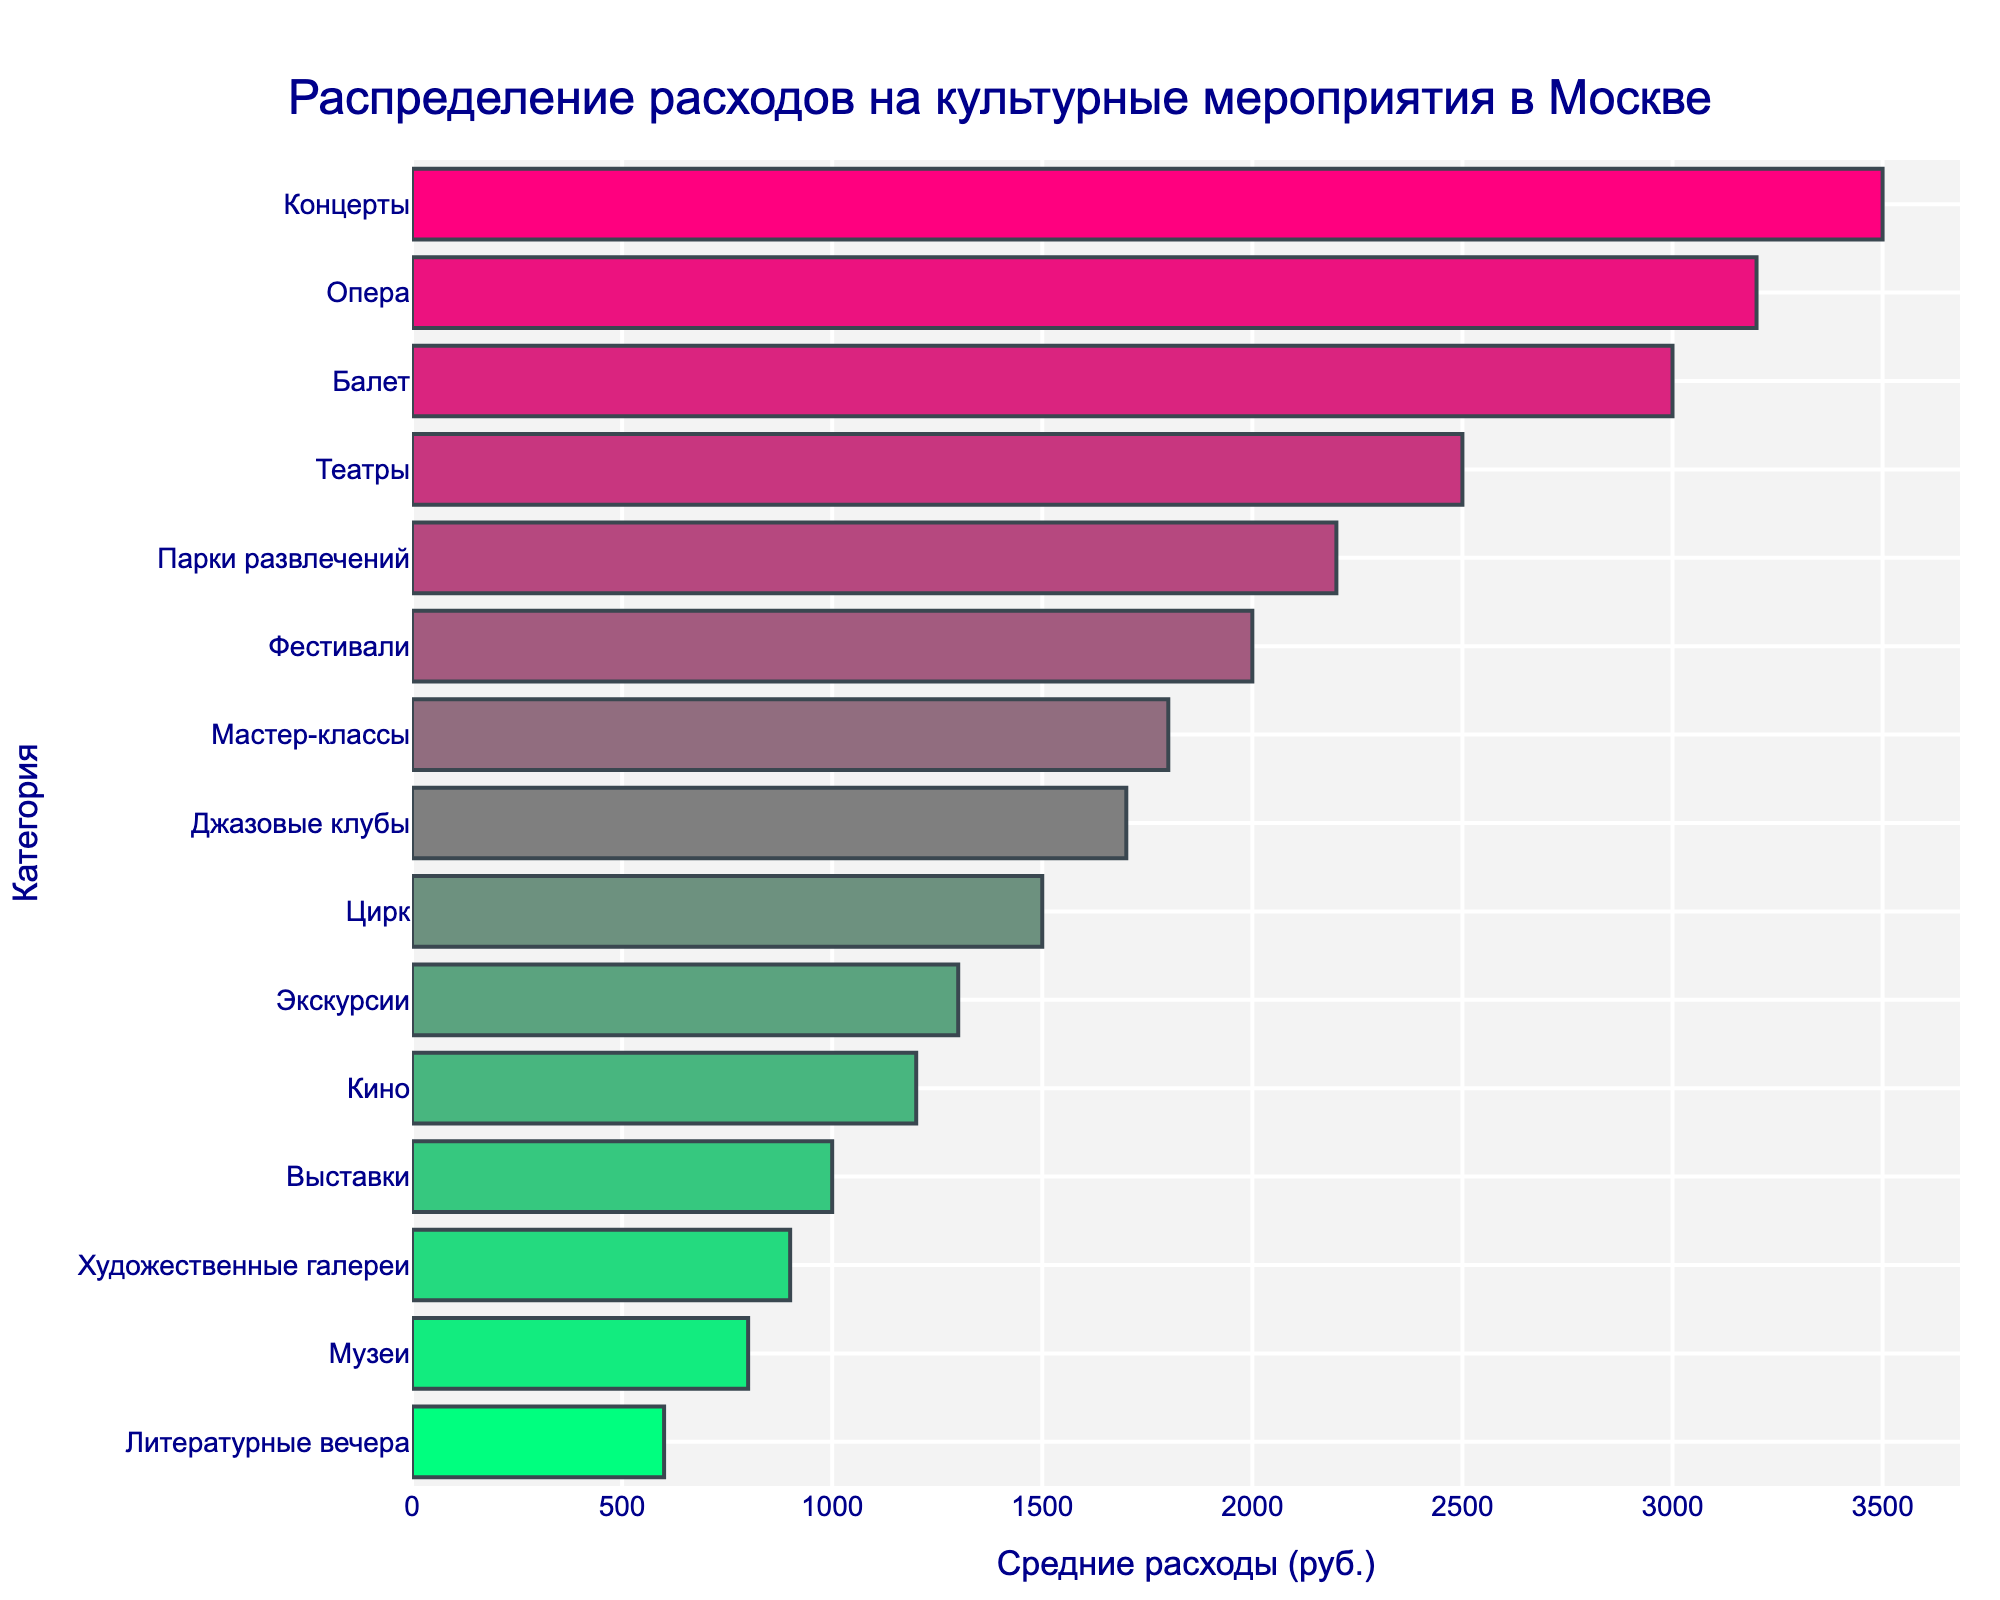Какая категория имеет наибольшие средние расходы? Внимательно глядя на горизонтальные столбцы в графике, категория с самым длинным столбцом означает наибольшие средние расходы. В данном случае, это категория "Концерты".
Answer: Концерты Какая сумма средних расходов на кино и музеи? Мы видим, что средние расходы на кино составляют 1200 рублей, а на музеи 800 рублей. Сложив их, получаем 1200 + 800 = 2000 рублей.
Answer: 2000 рублей Что дороже: посещение балета или оперы? Сравнив длины столбцов для категорий "Балет" и "Опера", можно увидеть, что столбец "Опера" длиннее, что означает больший средний расход. Балет — 3000 рублей, Опера — 3200 рублей.
Answer: Опера Каково общее количество категорий, представленных на графике? Посчитав количество всех горизонтальных столбцов, мы видим 15 различных категорий.
Answer: 15 Какая разница в средних расходах на театры и цирк? Средние расходы на театры составляют 2500 рублей, а на цирк — 1500 рублей. Разница между ними составляет 2500 - 1500 = 1000 рублей.
Answer: 1000 рублей Какие категории имеют средние расходы более 2000 рублей? Глядя на длину столбцов, которые достигают или превышают отметку 2000 рублей, можно определить следующие категории: Театры, Концерты, Балет, Опера и Парки развлечений.
Answer: Театры, Концерты, Балет, Опера, Парки развлечений Какая категория имеет самый короткий столбец на графике? Самый короткий столбец указывает на наименьшие средние расходы, что соответствует категории "Литературные вечера" со средними расходами в 600 рублей.
Answer: Литературные вечера Насколько средние расходы на художественные галереи меньше, чем на мастер-классы? Средние расходы на художественные галереи составляют 900 рублей, а на мастер-классы — 1800 рублей. Разница между ними составляет 1800 - 900 = 900 рублей.
Answer: 900 рублей Каков средний расход на джазовые клубы, цирк и экскурсии вместе взятые? Средние расходы на джазовые клубы составляют 1700 рублей, на цирк — 1500 рублей, и на экскурсии — 1300 рублей. Суммируем их: 1700 + 1500 + 1300 = 4500 рублей.
Answer: 4500 рублей 